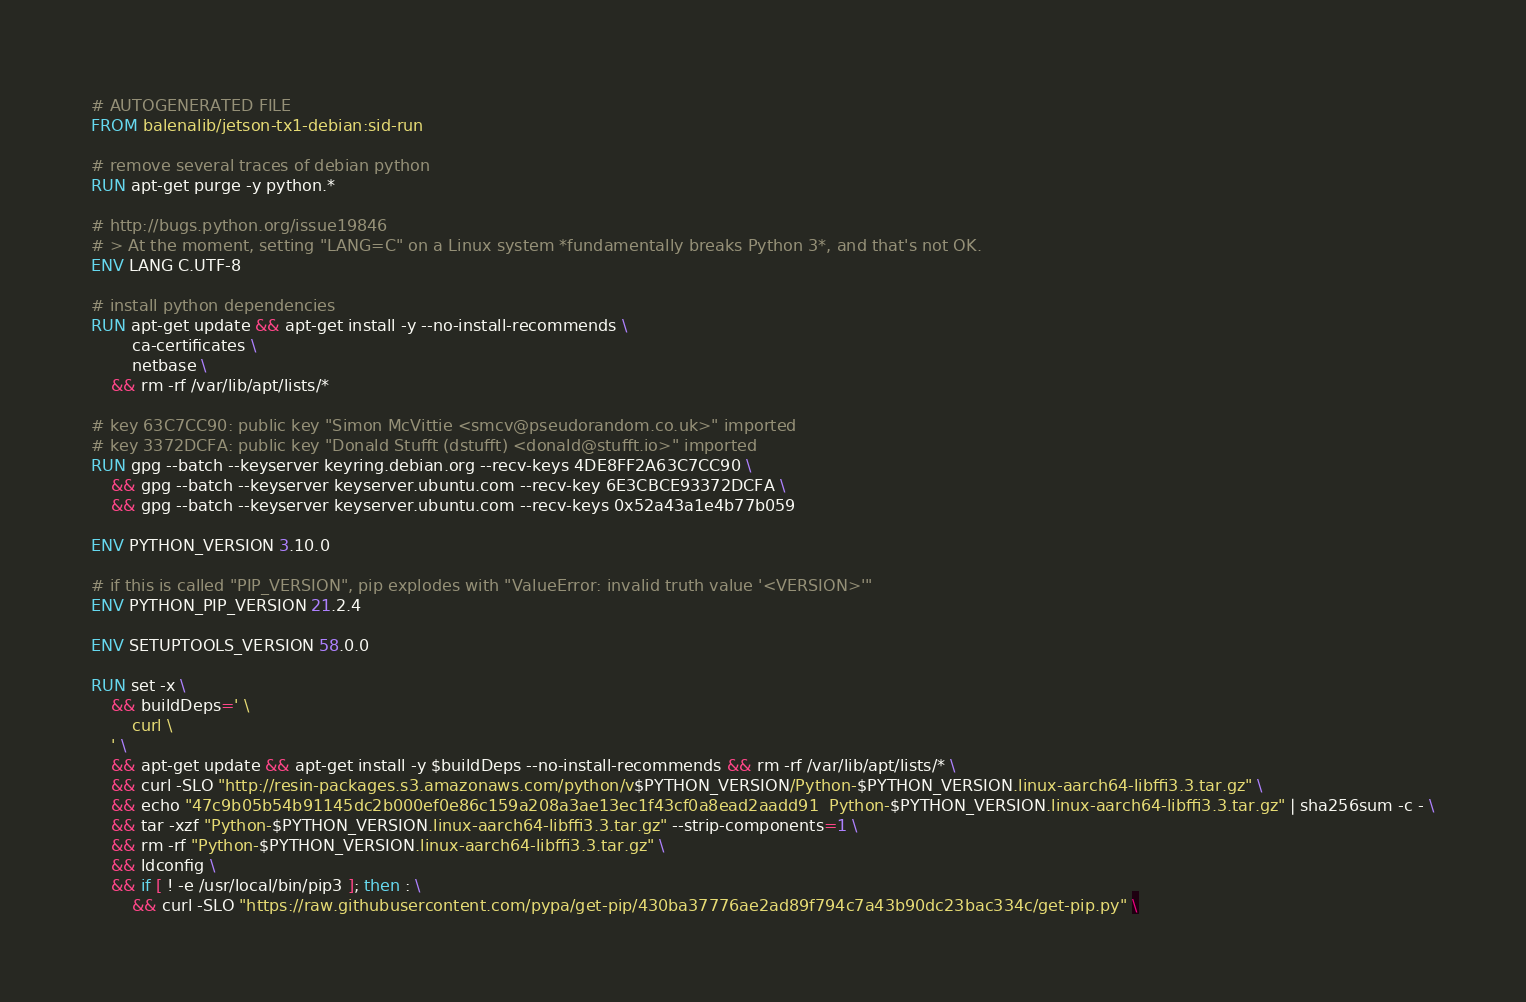Convert code to text. <code><loc_0><loc_0><loc_500><loc_500><_Dockerfile_># AUTOGENERATED FILE
FROM balenalib/jetson-tx1-debian:sid-run

# remove several traces of debian python
RUN apt-get purge -y python.*

# http://bugs.python.org/issue19846
# > At the moment, setting "LANG=C" on a Linux system *fundamentally breaks Python 3*, and that's not OK.
ENV LANG C.UTF-8

# install python dependencies
RUN apt-get update && apt-get install -y --no-install-recommends \
		ca-certificates \
		netbase \
	&& rm -rf /var/lib/apt/lists/*

# key 63C7CC90: public key "Simon McVittie <smcv@pseudorandom.co.uk>" imported
# key 3372DCFA: public key "Donald Stufft (dstufft) <donald@stufft.io>" imported
RUN gpg --batch --keyserver keyring.debian.org --recv-keys 4DE8FF2A63C7CC90 \
	&& gpg --batch --keyserver keyserver.ubuntu.com --recv-key 6E3CBCE93372DCFA \
	&& gpg --batch --keyserver keyserver.ubuntu.com --recv-keys 0x52a43a1e4b77b059

ENV PYTHON_VERSION 3.10.0

# if this is called "PIP_VERSION", pip explodes with "ValueError: invalid truth value '<VERSION>'"
ENV PYTHON_PIP_VERSION 21.2.4

ENV SETUPTOOLS_VERSION 58.0.0

RUN set -x \
	&& buildDeps=' \
		curl \
	' \
	&& apt-get update && apt-get install -y $buildDeps --no-install-recommends && rm -rf /var/lib/apt/lists/* \
	&& curl -SLO "http://resin-packages.s3.amazonaws.com/python/v$PYTHON_VERSION/Python-$PYTHON_VERSION.linux-aarch64-libffi3.3.tar.gz" \
	&& echo "47c9b05b54b91145dc2b000ef0e86c159a208a3ae13ec1f43cf0a8ead2aadd91  Python-$PYTHON_VERSION.linux-aarch64-libffi3.3.tar.gz" | sha256sum -c - \
	&& tar -xzf "Python-$PYTHON_VERSION.linux-aarch64-libffi3.3.tar.gz" --strip-components=1 \
	&& rm -rf "Python-$PYTHON_VERSION.linux-aarch64-libffi3.3.tar.gz" \
	&& ldconfig \
	&& if [ ! -e /usr/local/bin/pip3 ]; then : \
		&& curl -SLO "https://raw.githubusercontent.com/pypa/get-pip/430ba37776ae2ad89f794c7a43b90dc23bac334c/get-pip.py" \</code> 